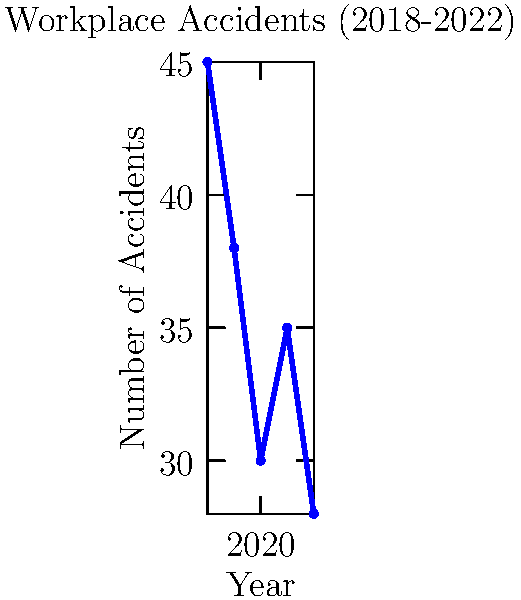As the regional director responsible for workplace safety, you are presented with the above line chart showing the trend of workplace accidents from 2018 to 2022. What is the overall percentage decrease in workplace accidents from 2018 to 2022? To calculate the overall percentage decrease in workplace accidents from 2018 to 2022, we need to follow these steps:

1. Identify the number of accidents in 2018 and 2022:
   - 2018: 45 accidents
   - 2022: 28 accidents

2. Calculate the decrease in the number of accidents:
   $45 - 28 = 17$ accidents

3. Calculate the percentage decrease:
   Percentage decrease = $\frac{\text{Decrease}}{\text{Original Value}} \times 100\%$
   
   $= \frac{17}{45} \times 100\%$
   
   $= 0.3777... \times 100\%$
   
   $= 37.77\%$

4. Round to the nearest whole percentage:
   $37.77\%$ rounds to $38\%$

Therefore, the overall percentage decrease in workplace accidents from 2018 to 2022 is 38%.
Answer: 38% 